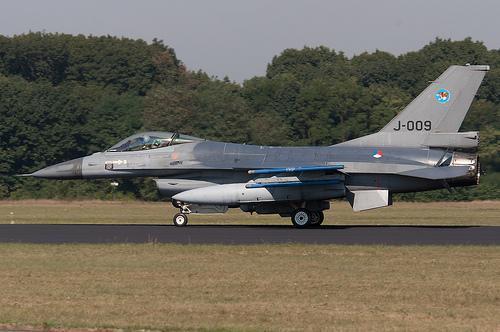How many jets are there?
Give a very brief answer. 1. How many wheels are there on the jet?
Give a very brief answer. 3. 